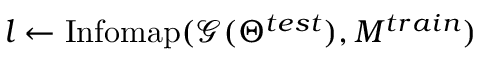Convert formula to latex. <formula><loc_0><loc_0><loc_500><loc_500>l \gets I n f o m a p ( \mathcal { G } ( \Theta ^ { t e s t } ) , M ^ { t r a i n } )</formula> 